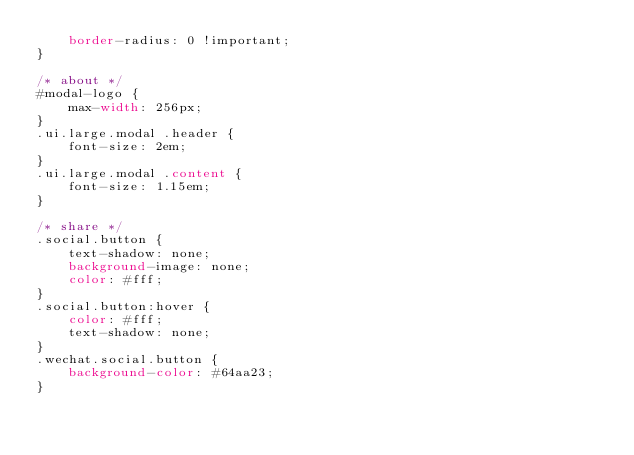Convert code to text. <code><loc_0><loc_0><loc_500><loc_500><_CSS_>    border-radius: 0 !important;
}

/* about */
#modal-logo {
    max-width: 256px;
}
.ui.large.modal .header {
    font-size: 2em;
}
.ui.large.modal .content {
    font-size: 1.15em;
}

/* share */
.social.button {
    text-shadow: none;
    background-image: none;
    color: #fff;
}
.social.button:hover {
    color: #fff;
    text-shadow: none;
}
.wechat.social.button {
    background-color: #64aa23;
}</code> 